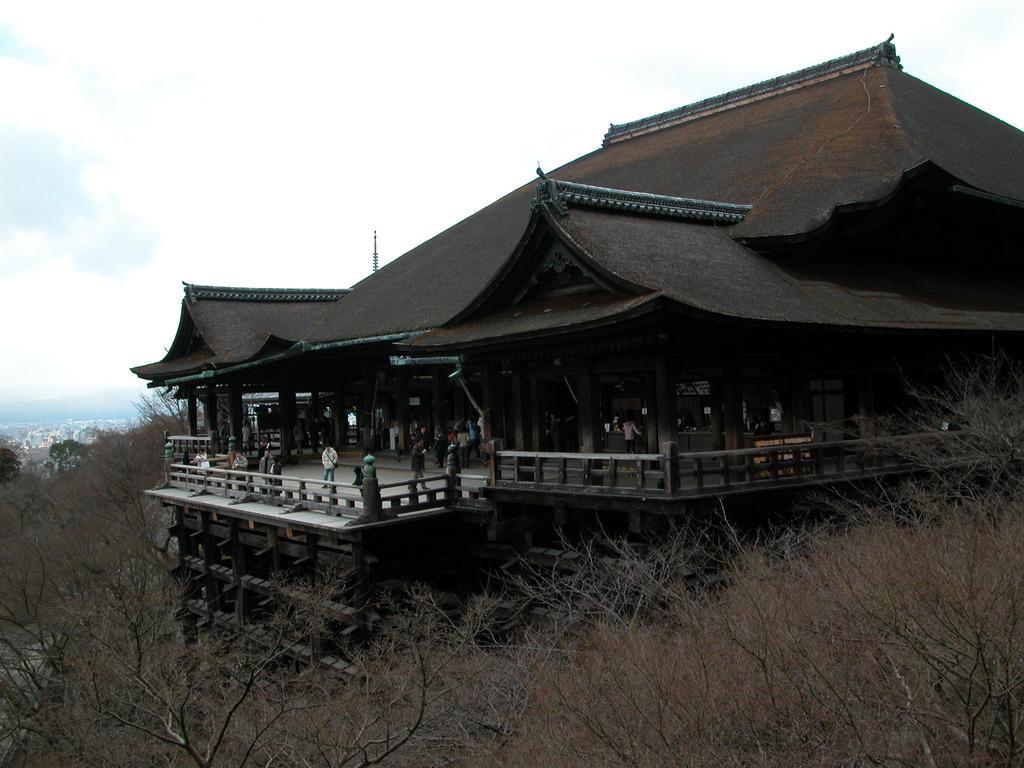Can you describe this image briefly? In this image we can see a building, there are some trees, people, fence, pillars and mountains, in the background, we can see the sky with clouds. 